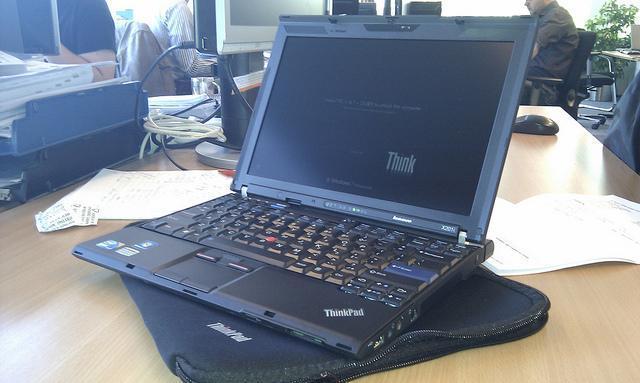How many people are there?
Give a very brief answer. 4. 